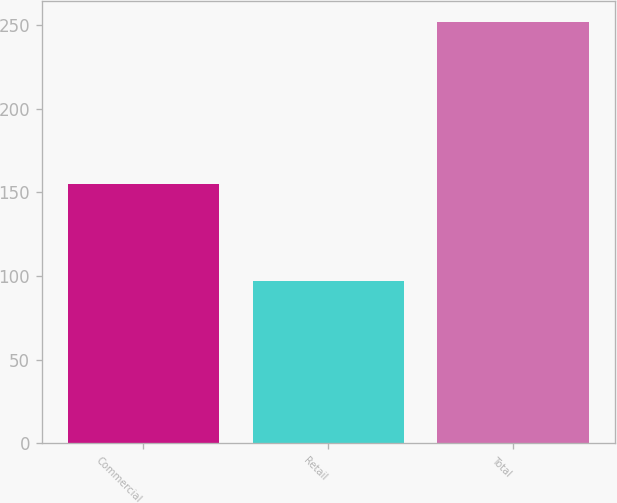<chart> <loc_0><loc_0><loc_500><loc_500><bar_chart><fcel>Commercial<fcel>Retail<fcel>Total<nl><fcel>155.1<fcel>97<fcel>252.1<nl></chart> 